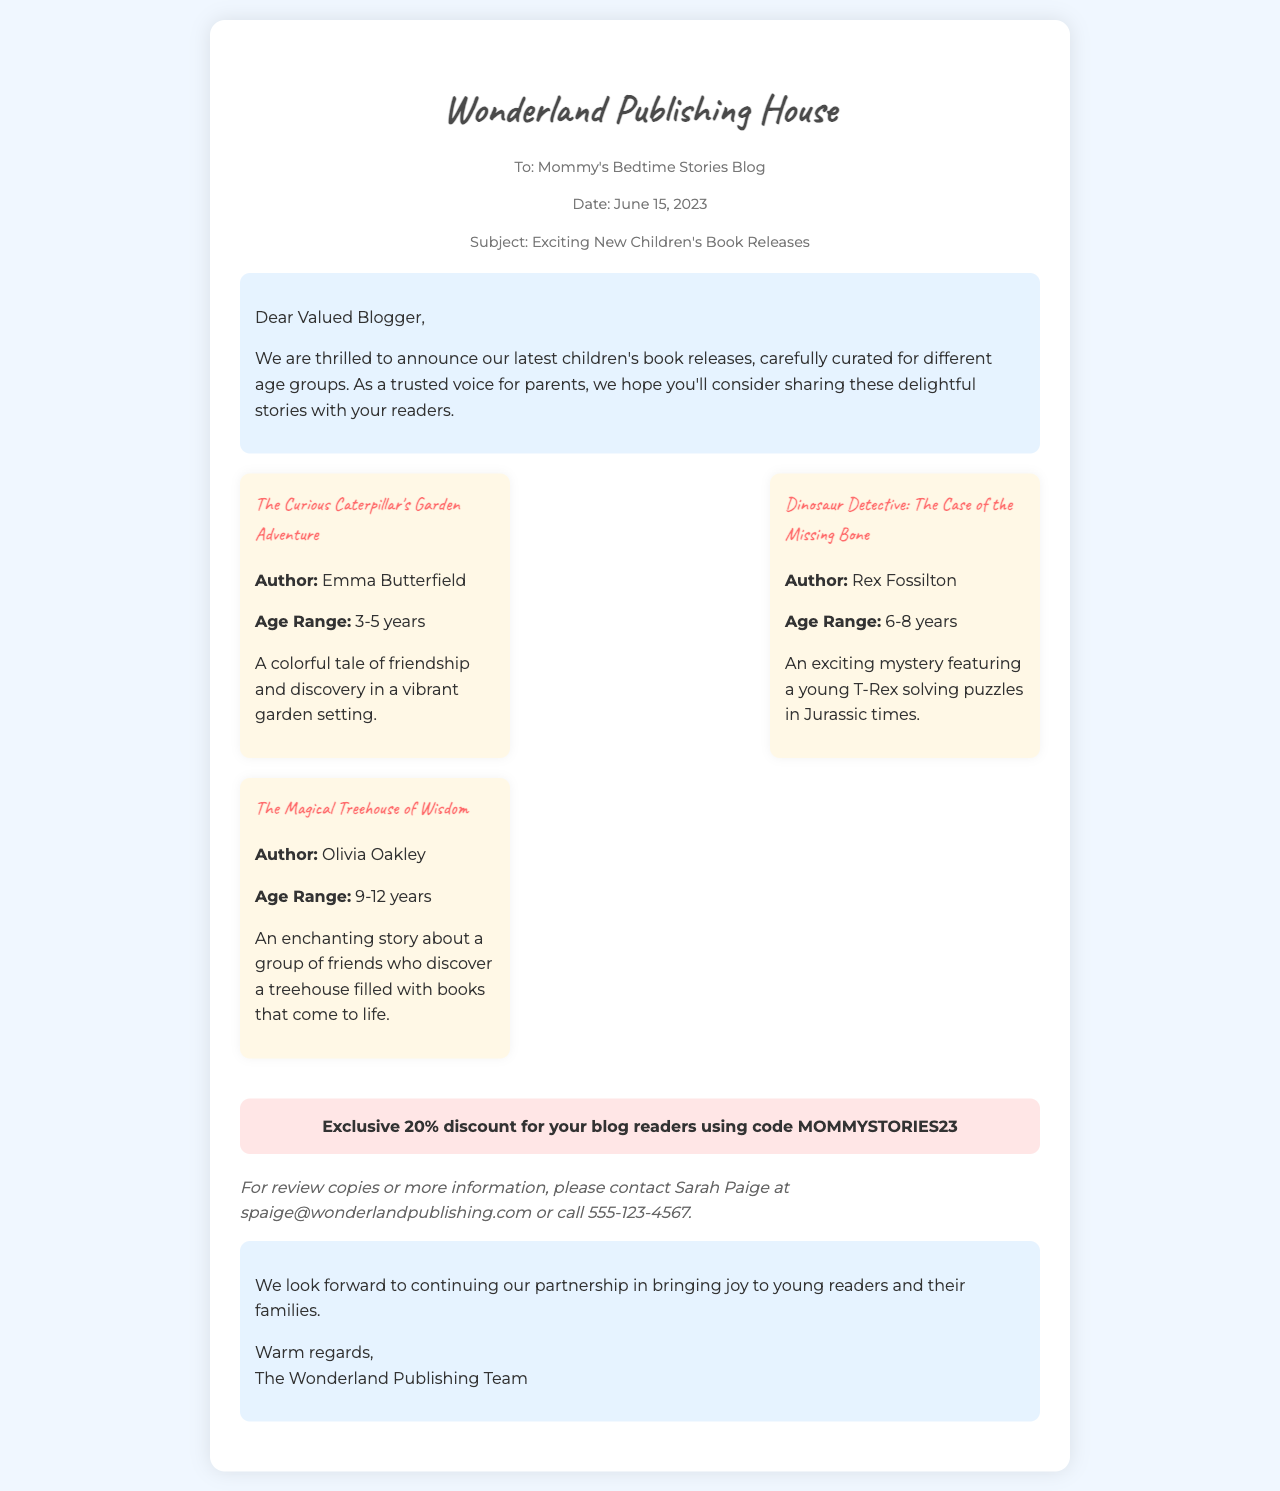what is the name of the first book mentioned? The first book mentioned is "The Curious Caterpillar's Garden Adventure," which is highlighted in the new releases section.
Answer: The Curious Caterpillar's Garden Adventure who is the author of the second book? The second book listed is "Dinosaur Detective: The Case of the Missing Bone," which is authored by Rex Fossilton.
Answer: Rex Fossilton what is the age range for "The Magical Treehouse of Wisdom"? This book is aimed at children aged 9-12 years, as noted in the age recommendations.
Answer: 9-12 years how much of a discount is offered to blog readers? The fax includes a special offer of a 20% discount, which is specifically announced for your blog readers.
Answer: 20% who should be contacted for review copies? Sarah Paige is mentioned as the contact person for review copies or more information in the closing section of the document.
Answer: Sarah Paige 